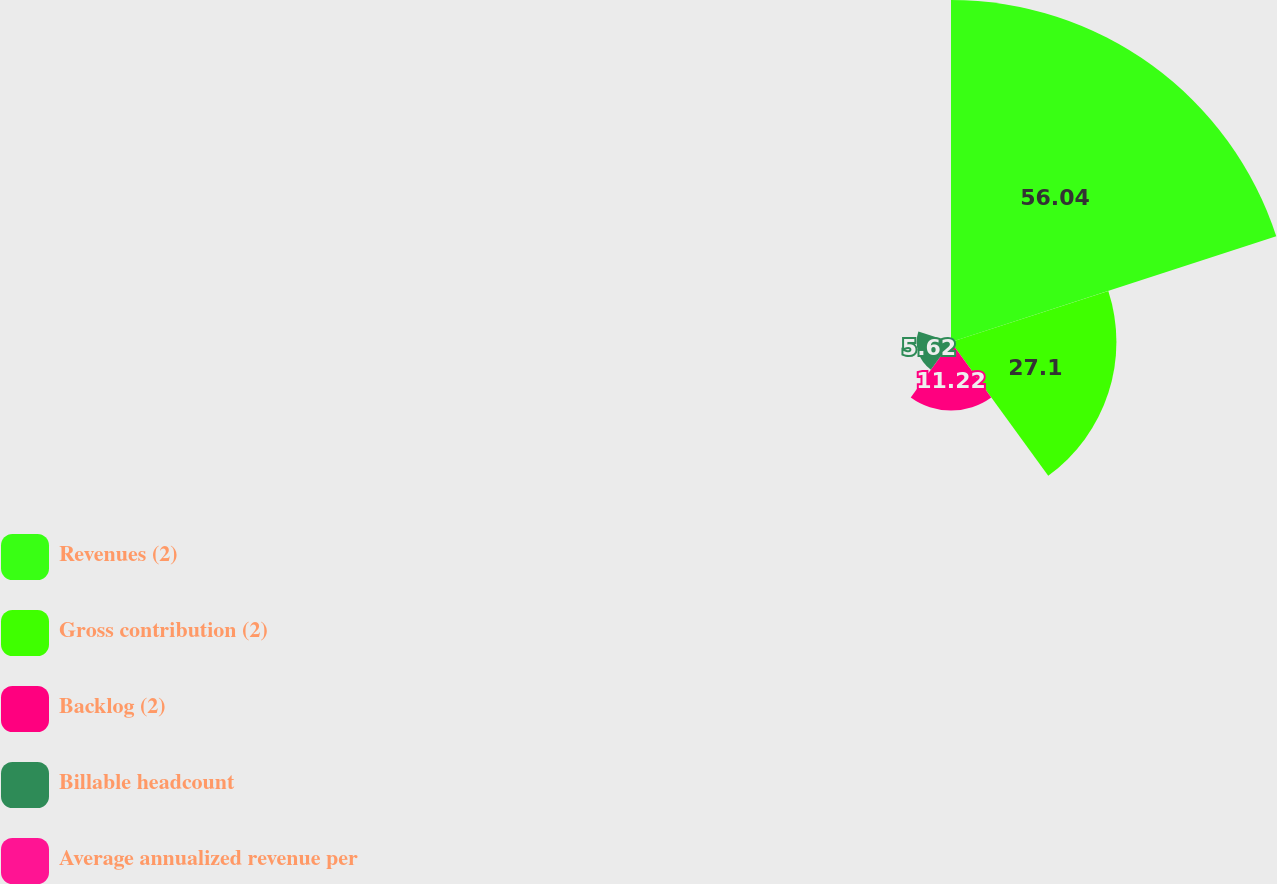Convert chart to OTSL. <chart><loc_0><loc_0><loc_500><loc_500><pie_chart><fcel>Revenues (2)<fcel>Gross contribution (2)<fcel>Backlog (2)<fcel>Billable headcount<fcel>Average annualized revenue per<nl><fcel>56.03%<fcel>27.1%<fcel>11.22%<fcel>5.62%<fcel>0.02%<nl></chart> 